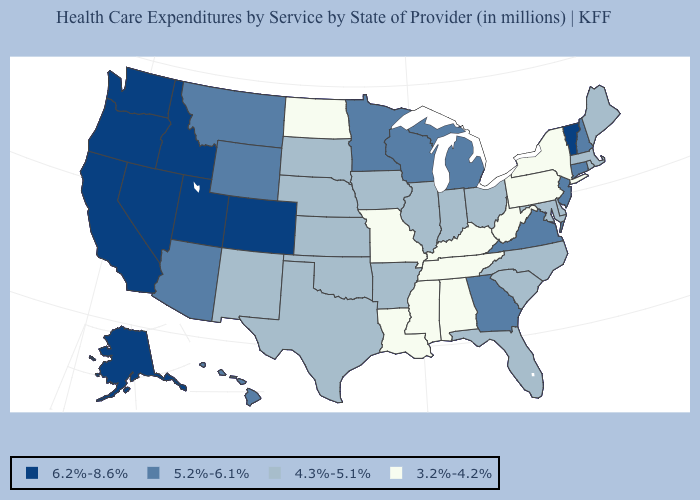Does West Virginia have the lowest value in the USA?
Give a very brief answer. Yes. Does North Dakota have the same value as Kentucky?
Be succinct. Yes. What is the value of Oklahoma?
Concise answer only. 4.3%-5.1%. Which states have the lowest value in the Northeast?
Be succinct. New York, Pennsylvania. Does West Virginia have the lowest value in the South?
Be succinct. Yes. Which states have the highest value in the USA?
Keep it brief. Alaska, California, Colorado, Idaho, Nevada, Oregon, Utah, Vermont, Washington. Name the states that have a value in the range 4.3%-5.1%?
Answer briefly. Arkansas, Delaware, Florida, Illinois, Indiana, Iowa, Kansas, Maine, Maryland, Massachusetts, Nebraska, New Mexico, North Carolina, Ohio, Oklahoma, Rhode Island, South Carolina, South Dakota, Texas. What is the value of Minnesota?
Quick response, please. 5.2%-6.1%. Does West Virginia have the highest value in the USA?
Write a very short answer. No. Does the first symbol in the legend represent the smallest category?
Short answer required. No. Name the states that have a value in the range 6.2%-8.6%?
Write a very short answer. Alaska, California, Colorado, Idaho, Nevada, Oregon, Utah, Vermont, Washington. Name the states that have a value in the range 4.3%-5.1%?
Concise answer only. Arkansas, Delaware, Florida, Illinois, Indiana, Iowa, Kansas, Maine, Maryland, Massachusetts, Nebraska, New Mexico, North Carolina, Ohio, Oklahoma, Rhode Island, South Carolina, South Dakota, Texas. Name the states that have a value in the range 4.3%-5.1%?
Write a very short answer. Arkansas, Delaware, Florida, Illinois, Indiana, Iowa, Kansas, Maine, Maryland, Massachusetts, Nebraska, New Mexico, North Carolina, Ohio, Oklahoma, Rhode Island, South Carolina, South Dakota, Texas. Does Maine have the same value as New York?
Be succinct. No. What is the highest value in states that border Kansas?
Write a very short answer. 6.2%-8.6%. 